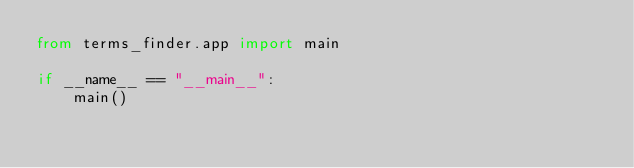Convert code to text. <code><loc_0><loc_0><loc_500><loc_500><_Python_>from terms_finder.app import main

if __name__ == "__main__":
    main()
</code> 